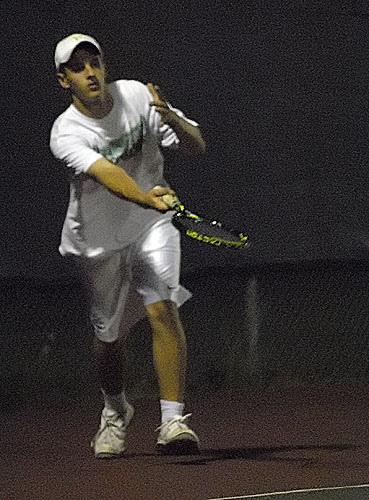Is the guy wearing shorts?
Write a very short answer. Yes. What is the color of the guy's socks?
Quick response, please. White. What game is he playing?
Quick response, please. Tennis. 